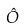<formula> <loc_0><loc_0><loc_500><loc_500>\hat { O }</formula> 